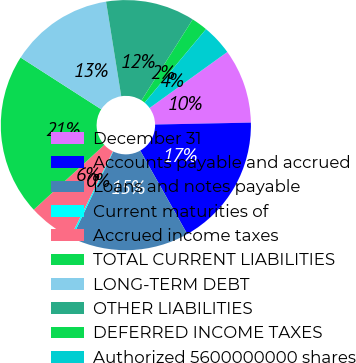Convert chart. <chart><loc_0><loc_0><loc_500><loc_500><pie_chart><fcel>December 31<fcel>Accounts payable and accrued<fcel>Loans and notes payable<fcel>Current maturities of<fcel>Accrued income taxes<fcel>TOTAL CURRENT LIABILITIES<fcel>LONG-TERM DEBT<fcel>OTHER LIABILITIES<fcel>DEFERRED INCOME TAXES<fcel>Authorized 5600000000 shares<nl><fcel>9.62%<fcel>17.14%<fcel>15.26%<fcel>0.22%<fcel>5.86%<fcel>20.9%<fcel>13.38%<fcel>11.5%<fcel>2.1%<fcel>3.98%<nl></chart> 